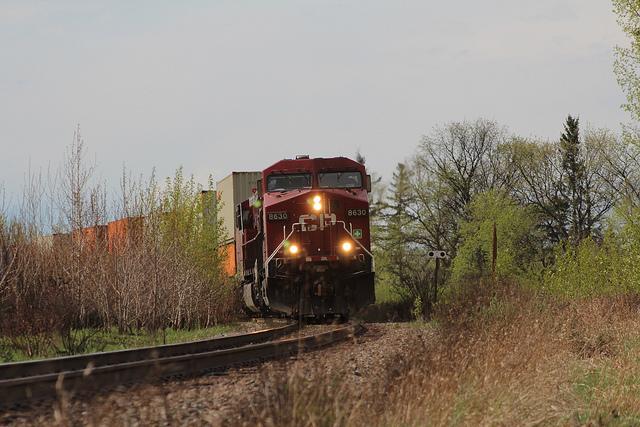What is the machinery called?
Be succinct. Train. Do the bushes framing the front of the train in the photo need trimming?
Be succinct. Yes. Why are the lights on?
Write a very short answer. Safety. What make of vehicle is it?
Quick response, please. Train. Does there appear to be mountains in the background of this scene?
Short answer required. No. What is the black and red item?
Short answer required. Train. Can you see a train?
Answer briefly. Yes. Could a deer jump in front of that train?
Write a very short answer. Yes. Does anyone appear to be operating this machinery at the moment?
Give a very brief answer. Yes. How many lights are on the front of the train?
Answer briefly. 4. Have trees lost their leaves?
Quick response, please. Yes. What color are the trees in this picture?
Give a very brief answer. Green. What type of train is this?
Quick response, please. Cargo. What is on the track?
Quick response, please. Train. 